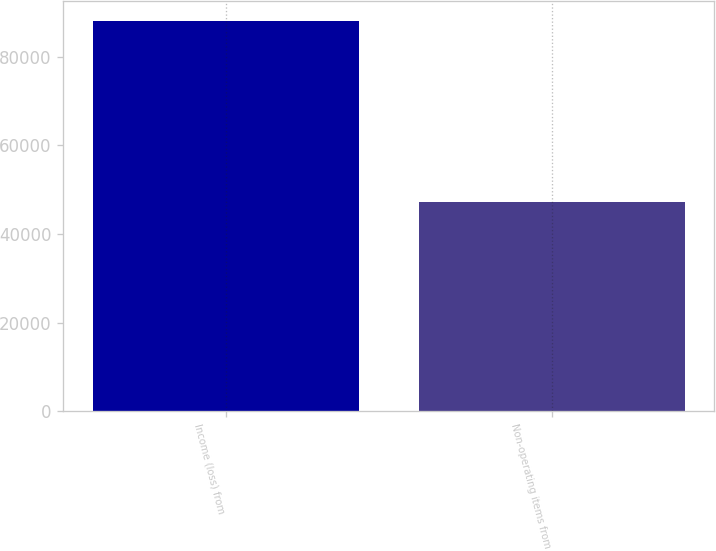Convert chart to OTSL. <chart><loc_0><loc_0><loc_500><loc_500><bar_chart><fcel>Income (loss) from<fcel>Non-operating items from<nl><fcel>88227<fcel>47127<nl></chart> 